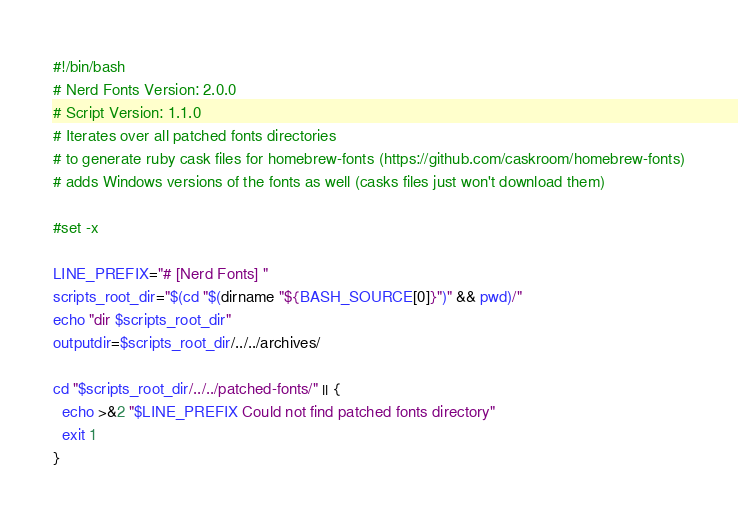<code> <loc_0><loc_0><loc_500><loc_500><_Bash_>#!/bin/bash
# Nerd Fonts Version: 2.0.0
# Script Version: 1.1.0
# Iterates over all patched fonts directories
# to generate ruby cask files for homebrew-fonts (https://github.com/caskroom/homebrew-fonts)
# adds Windows versions of the fonts as well (casks files just won't download them)

#set -x

LINE_PREFIX="# [Nerd Fonts] "
scripts_root_dir="$(cd "$(dirname "${BASH_SOURCE[0]}")" && pwd)/"
echo "dir $scripts_root_dir"
outputdir=$scripts_root_dir/../../archives/

cd "$scripts_root_dir/../../patched-fonts/" || {
  echo >&2 "$LINE_PREFIX Could not find patched fonts directory"
  exit 1
}
</code> 